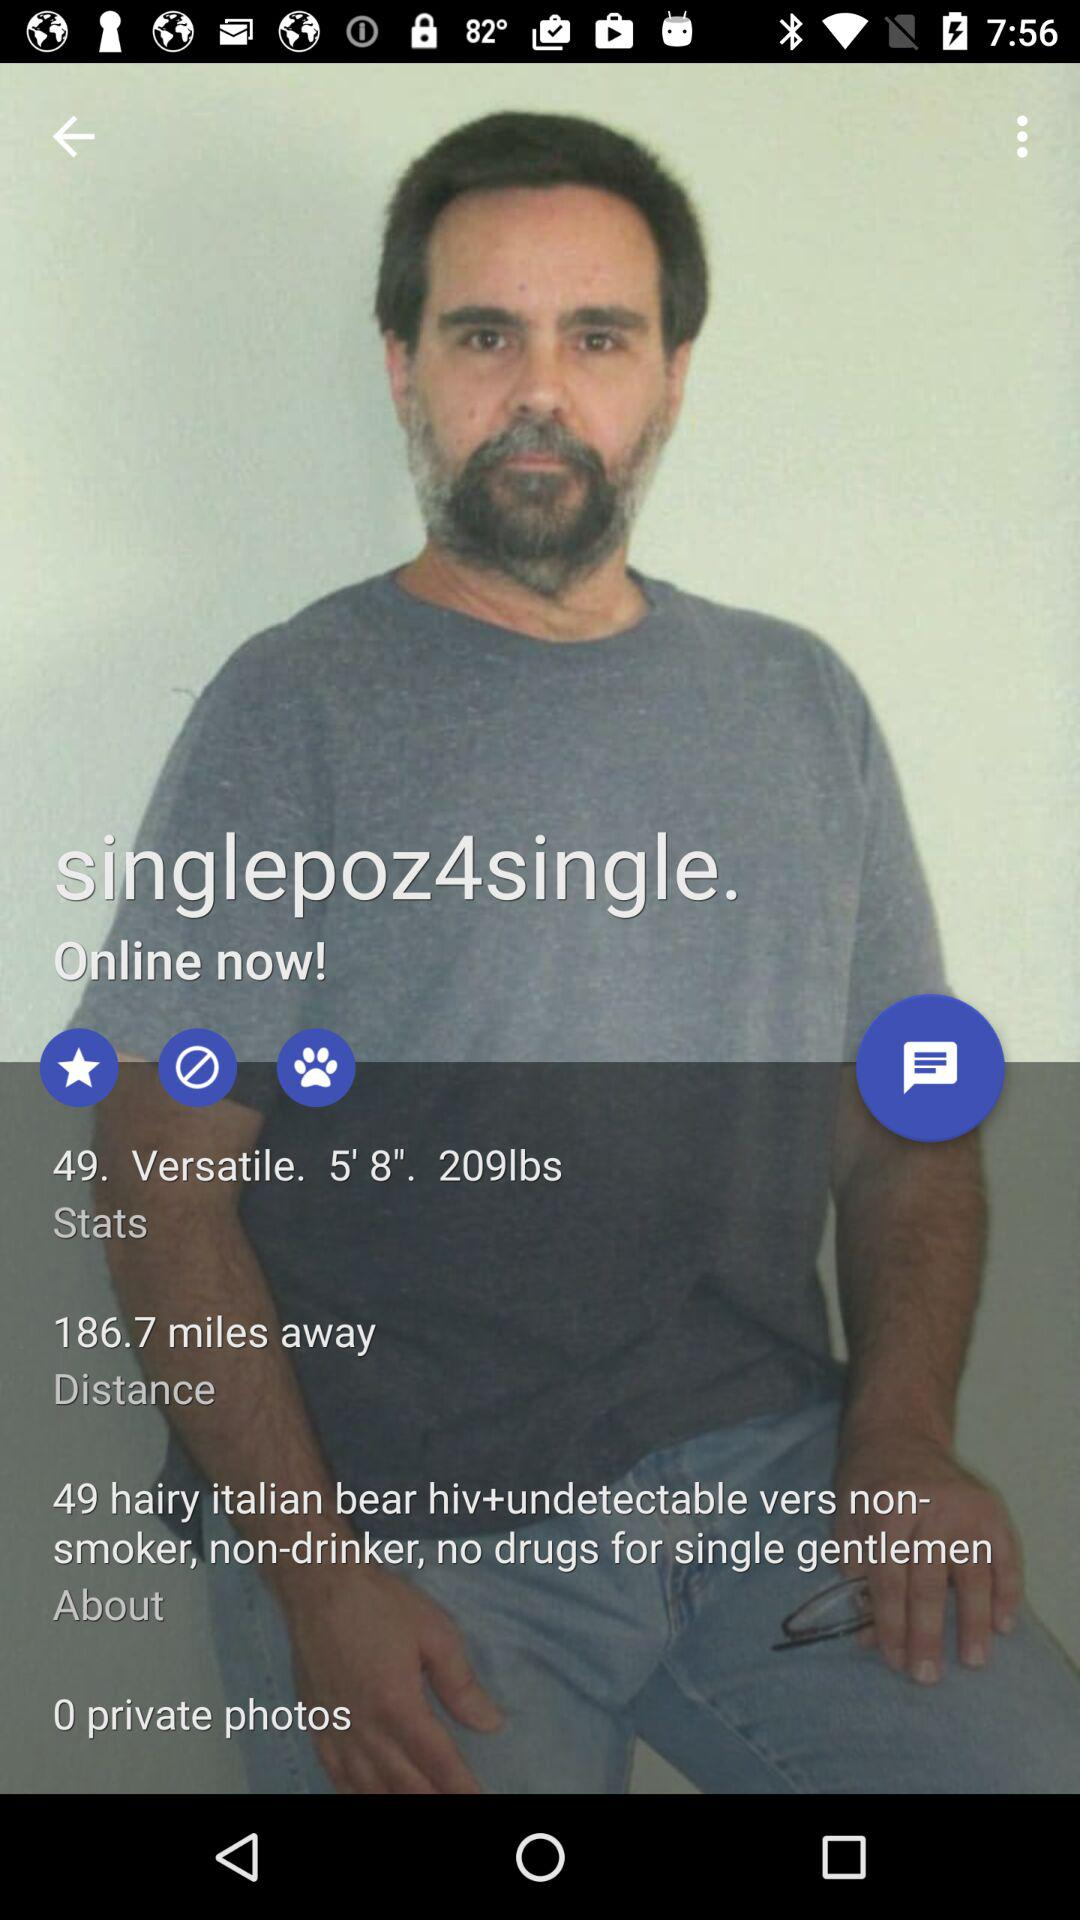What is the username? The username is "singlepoz4single.". 